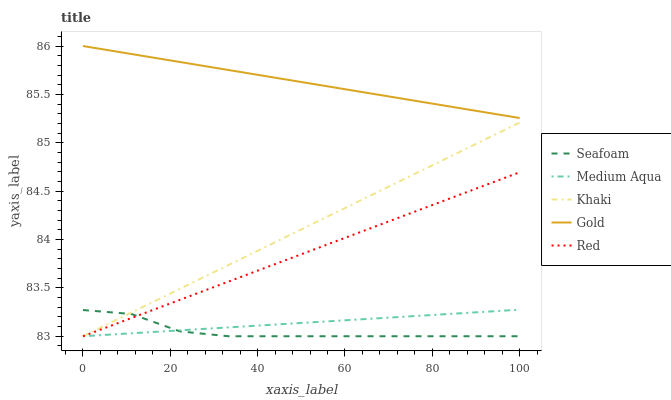Does Khaki have the minimum area under the curve?
Answer yes or no. No. Does Khaki have the maximum area under the curve?
Answer yes or no. No. Is Khaki the smoothest?
Answer yes or no. No. Is Khaki the roughest?
Answer yes or no. No. Does Gold have the lowest value?
Answer yes or no. No. Does Khaki have the highest value?
Answer yes or no. No. Is Khaki less than Gold?
Answer yes or no. Yes. Is Gold greater than Khaki?
Answer yes or no. Yes. Does Khaki intersect Gold?
Answer yes or no. No. 